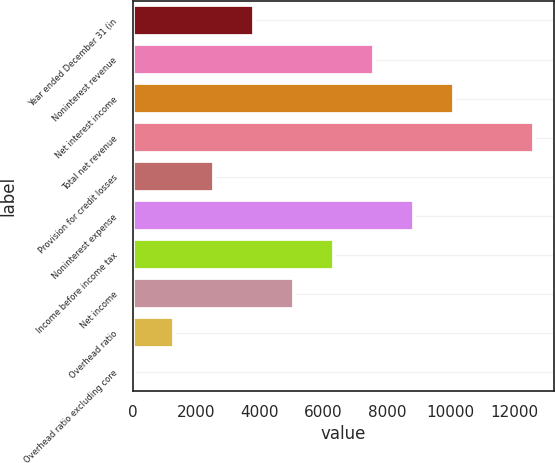<chart> <loc_0><loc_0><loc_500><loc_500><bar_chart><fcel>Year ended December 31 (in<fcel>Noninterest revenue<fcel>Net interest income<fcel>Total net revenue<fcel>Provision for credit losses<fcel>Noninterest expense<fcel>Income before income tax<fcel>Net income<fcel>Overhead ratio<fcel>Overhead ratio excluding core<nl><fcel>3820.8<fcel>7587.6<fcel>10098.8<fcel>12610<fcel>2565.2<fcel>8843.2<fcel>6332<fcel>5076.4<fcel>1309.6<fcel>54<nl></chart> 